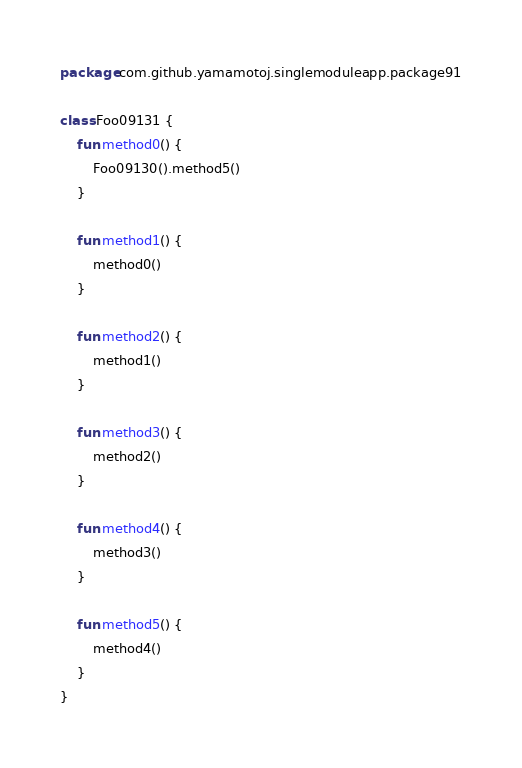<code> <loc_0><loc_0><loc_500><loc_500><_Kotlin_>package com.github.yamamotoj.singlemoduleapp.package91

class Foo09131 {
    fun method0() {
        Foo09130().method5()
    }

    fun method1() {
        method0()
    }

    fun method2() {
        method1()
    }

    fun method3() {
        method2()
    }

    fun method4() {
        method3()
    }

    fun method5() {
        method4()
    }
}
</code> 